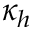<formula> <loc_0><loc_0><loc_500><loc_500>\kappa _ { h }</formula> 